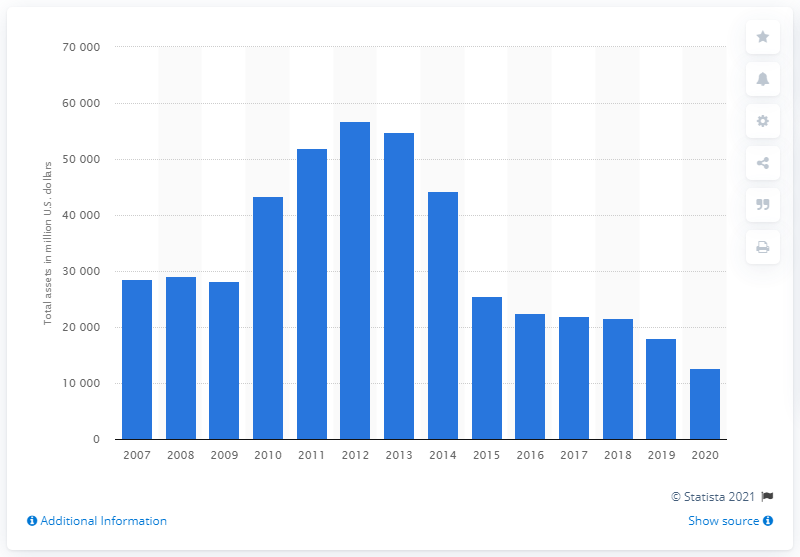Specify some key components in this picture. Apache Corporation's total assets in the year prior were 18,107. Apache Corporation's total assets in dollars in 2020 were 127,431. 